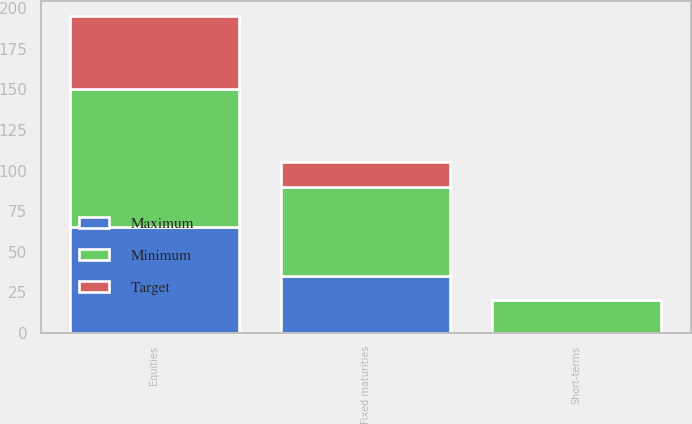Convert chart to OTSL. <chart><loc_0><loc_0><loc_500><loc_500><stacked_bar_chart><ecel><fcel>Equities<fcel>Fixed maturities<fcel>Short-terms<nl><fcel>Maximum<fcel>65<fcel>35<fcel>0<nl><fcel>Target<fcel>45<fcel>15<fcel>0<nl><fcel>Minimum<fcel>85<fcel>55<fcel>20<nl></chart> 